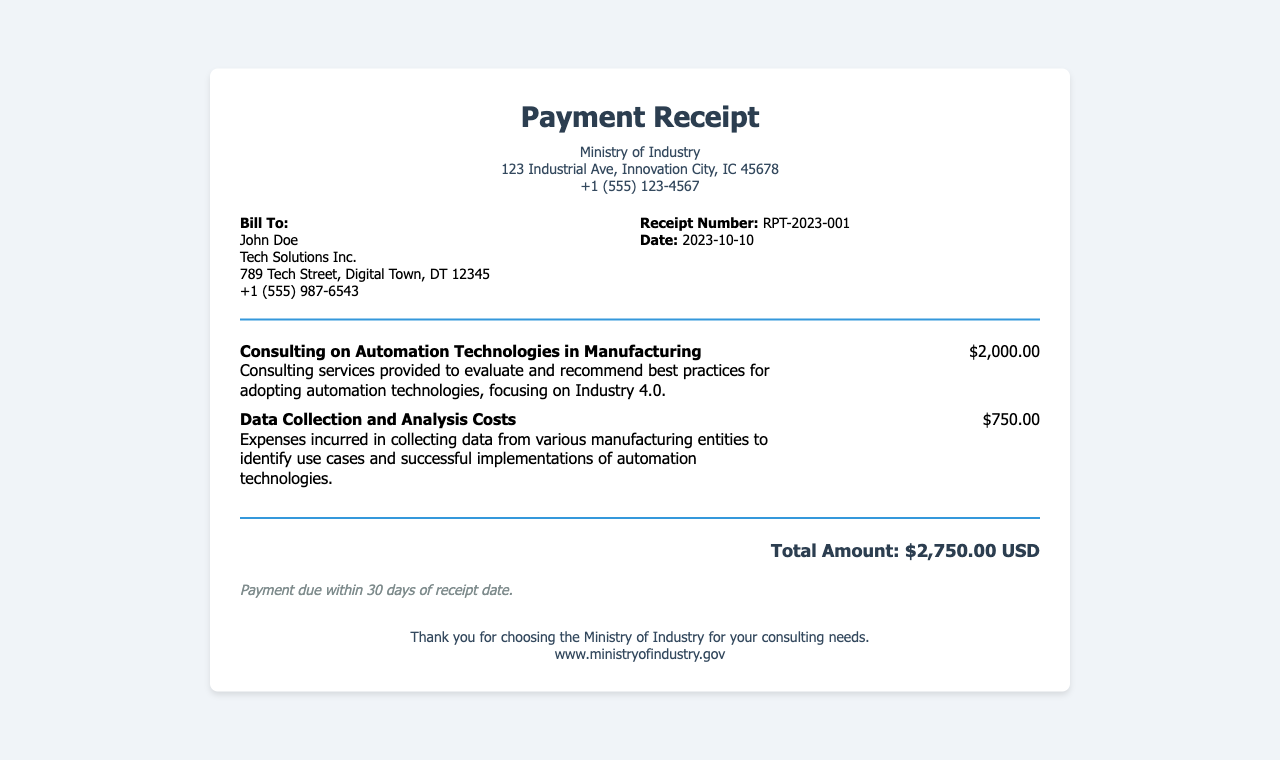What is the receipt number? The receipt number is displayed in the receipt details section.
Answer: RPT-2023-001 What is the date of the receipt? The date is listed along with the receipt number in the receipt details section.
Answer: 2023-10-10 Who is billed in this receipt? The billing information identifies the person or entity responsible for payment.
Answer: John Doe What is the fee for consulting services? The consulting fee is a specific charge outlined in the services section.
Answer: $2,000.00 What is the total amount due? The total amount is provided at the bottom of the receipt, summarizing all charges.
Answer: $2,750.00 USD What is the deadline for payment? The payment terms provide information about when the payment is due.
Answer: 30 days What type of consulting services were provided? The service description provides insight into the kind of services rendered in this consultancy.
Answer: Automation Technologies in Manufacturing What was the purpose of the data collection? The service description outlines the objectives related to data collection in this context.
Answer: Identify use cases and successful implementations What organization issued the receipt? The header of the document specifies which organization provided the receipt.
Answer: Ministry of Industry 